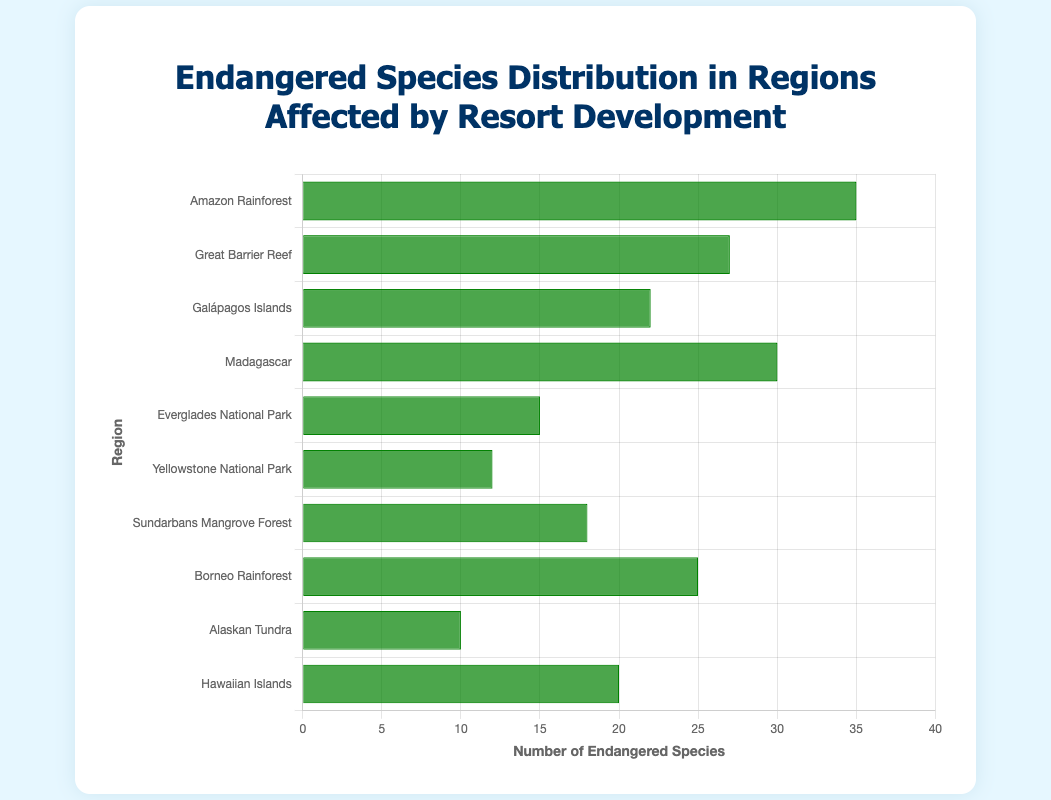Which region has the highest number of endangered species? The Amazon Rainforest has the highest bar in the chart when comparing the lengths of all the bars, which represents the highest number of endangered species.
Answer: Amazon Rainforest Which region has fewer endangered species: Yellowstone National Park or the Everglades National Park? Comparing the lengths of the bars for Yellowstone National Park and Everglades National Park, the bar for Yellowstone is shorter than the bar for the Everglades, indicating that Yellowstone has fewer endangered species.
Answer: Yellowstone National Park What is the total number of endangered species in the Great Barrier Reef and the Galápagos Islands? The number of endangered species in the Great Barrier Reef is 27 and in the Galápagos Islands is 22. Summing them up, 27 + 22 = 49.
Answer: 49 How many more endangered species does Madagascar have compared to the Hawaiian Islands? Madagascar has 30 endangered species and the Hawaiian Islands have 20. The difference is 30 - 20 = 10.
Answer: 10 What's the average number of endangered species across all regions? Summing up all the endangered species counts: 35 (Amazon) + 27 (Great Barrier Reef) + 22 (Galápagos) + 30 (Madagascar) + 15 (Everglades) + 12 (Yellowstone) + 18 (Sundarbans) + 25 (Borneo) + 10 (Alaskan Tundra) + 20 (Hawaiian Islands) = 214. Dividing by the number of regions (10), the average is 214 / 10 = 21.4.
Answer: 21.4 Which region has exactly twice as many endangered species as the Alaskan Tundra? The Alaskan Tundra has 10 endangered species, so twice as many is 10 * 2 = 20. The Hawaiian Islands have 20 endangered species, matching this criterion.
Answer: Hawaiian Islands Is the number of endangered species in the Sundarbans Mangrove Forest greater than in the Borneo Rainforest? Comparing the lengths of the bars for Sundarbans Mangrove Forest (18) and Borneo Rainforest (25), the Sundarbans bar is shorter, meaning it has fewer endangered species than the Borneo Rainforest.
Answer: No What is the difference in the number of endangered species between the Amazon Rainforest and the least affected region? The Amazon Rainforest has 35 species, and the Alaskan Tundra, the least affected region, has 10. The difference is 35 - 10 = 25.
Answer: 25 What's the median number of endangered species among all the regions? Sorting the endangered species counts: 10, 12, 15, 18, 20, 22, 25, 27, 30, 35. The middle values of the sorted count (fifth and sixth) are 20 and 22, so the median is (20 + 22) / 2 = 21.
Answer: 21 Which region has endangered species counts closest to the mean? With the mean being 21.4, the closest counts are 22 (Galápagos Islands) and 20 (Hawaiian Islands).
Answer: Galápagos Islands and Hawaiian Islands 